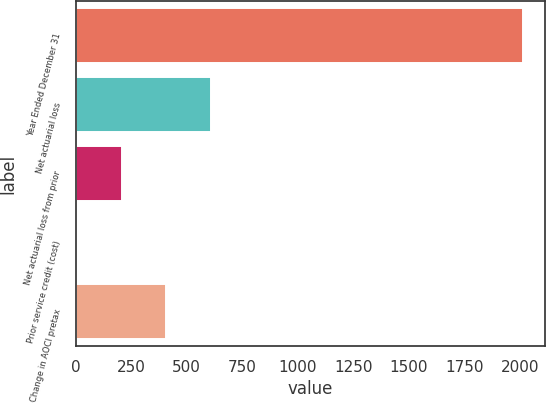Convert chart to OTSL. <chart><loc_0><loc_0><loc_500><loc_500><bar_chart><fcel>Year Ended December 31<fcel>Net actuarial loss<fcel>Net actuarial loss from prior<fcel>Prior service credit (cost)<fcel>Change in AOCI pretax<nl><fcel>2012<fcel>608.5<fcel>207.5<fcel>7<fcel>408<nl></chart> 